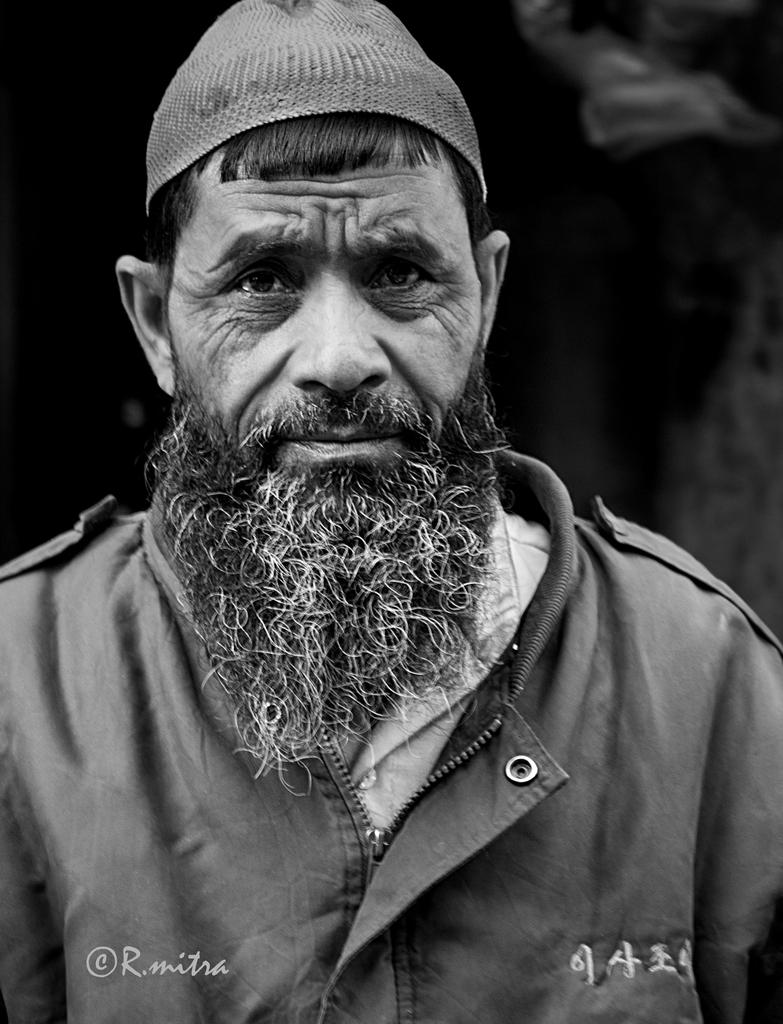What is the color scheme of the image? The image is black and white. Who is present in the image? There is a man in the image. What is the man doing in the image? The man is looking to his side. What type of clothing is the man wearing? The man is wearing a coat and a cap. What facial feature can be observed on the man? The man has a beard. What type of plastic box is the man holding in the image? There is no plastic box present in the image. 